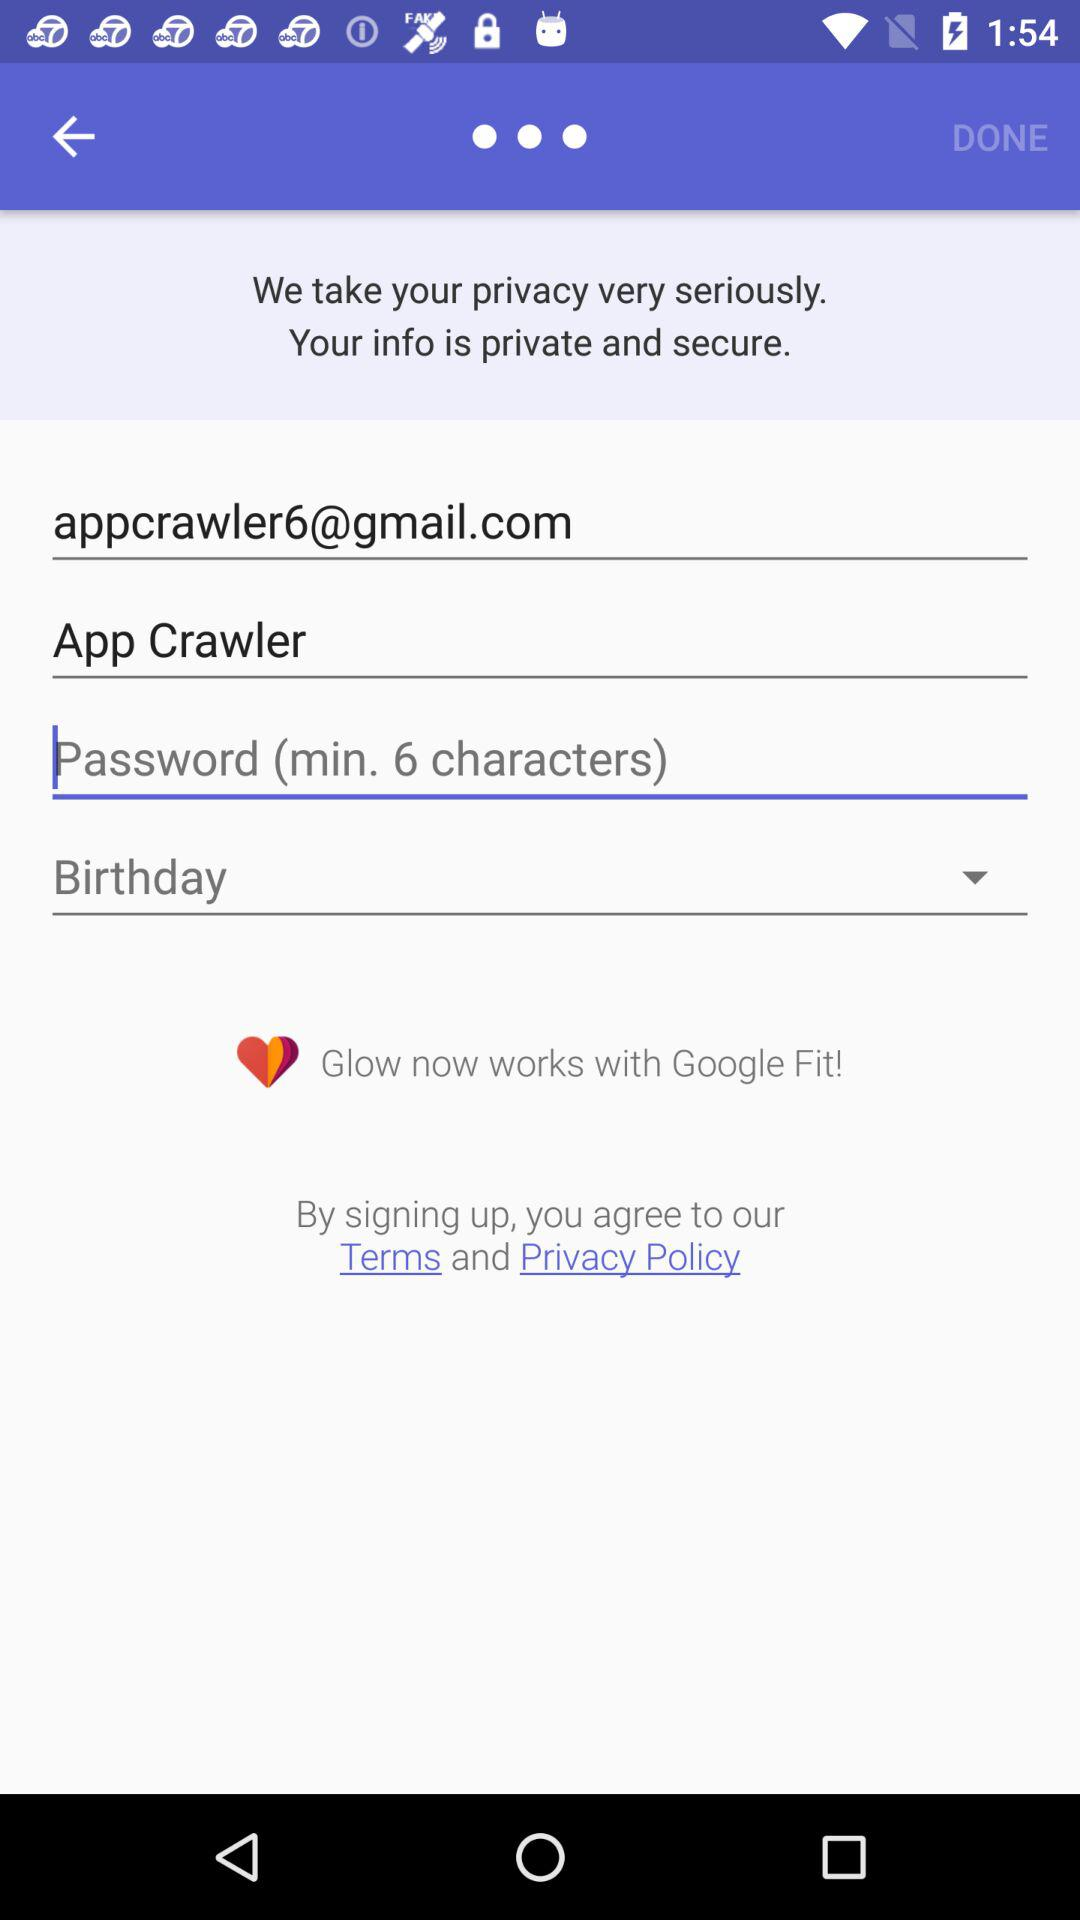What is the given name? The given name is App Crawler. 